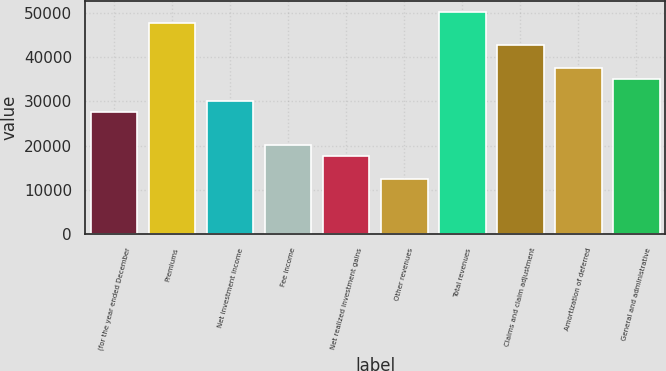<chart> <loc_0><loc_0><loc_500><loc_500><bar_chart><fcel>(for the year ended December<fcel>Premiums<fcel>Net investment income<fcel>Fee income<fcel>Net realized investment gains<fcel>Other revenues<fcel>Total revenues<fcel>Claims and claim adjustment<fcel>Amortization of deferred<fcel>General and administrative<nl><fcel>27623.1<fcel>47712.1<fcel>30134.2<fcel>20089.8<fcel>17578.6<fcel>12556.4<fcel>50223.2<fcel>42689.8<fcel>37667.6<fcel>35156.5<nl></chart> 